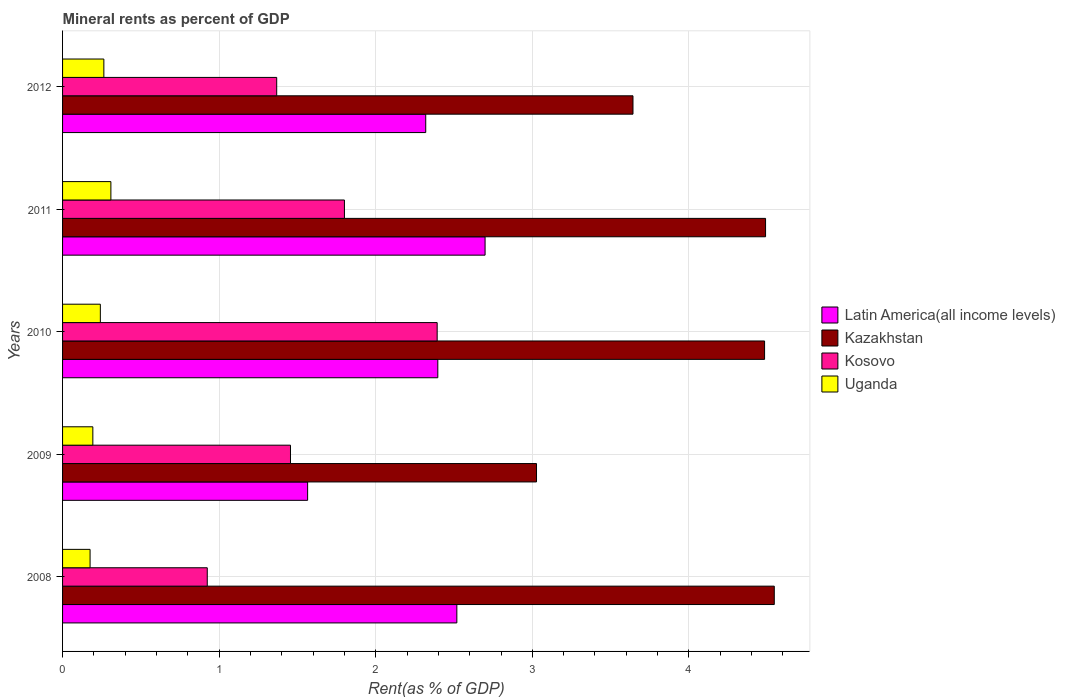How many different coloured bars are there?
Keep it short and to the point. 4. How many groups of bars are there?
Ensure brevity in your answer.  5. Are the number of bars per tick equal to the number of legend labels?
Keep it short and to the point. Yes. Are the number of bars on each tick of the Y-axis equal?
Your answer should be compact. Yes. How many bars are there on the 4th tick from the bottom?
Provide a short and direct response. 4. What is the mineral rent in Kosovo in 2012?
Your response must be concise. 1.37. Across all years, what is the maximum mineral rent in Kosovo?
Give a very brief answer. 2.39. Across all years, what is the minimum mineral rent in Uganda?
Keep it short and to the point. 0.18. What is the total mineral rent in Latin America(all income levels) in the graph?
Offer a very short reply. 11.5. What is the difference between the mineral rent in Latin America(all income levels) in 2008 and that in 2009?
Your response must be concise. 0.95. What is the difference between the mineral rent in Latin America(all income levels) in 2008 and the mineral rent in Uganda in 2012?
Your answer should be compact. 2.25. What is the average mineral rent in Kosovo per year?
Your answer should be compact. 1.59. In the year 2009, what is the difference between the mineral rent in Uganda and mineral rent in Latin America(all income levels)?
Your answer should be compact. -1.37. What is the ratio of the mineral rent in Latin America(all income levels) in 2010 to that in 2012?
Keep it short and to the point. 1.03. Is the difference between the mineral rent in Uganda in 2010 and 2012 greater than the difference between the mineral rent in Latin America(all income levels) in 2010 and 2012?
Offer a terse response. No. What is the difference between the highest and the second highest mineral rent in Latin America(all income levels)?
Give a very brief answer. 0.18. What is the difference between the highest and the lowest mineral rent in Uganda?
Offer a terse response. 0.13. In how many years, is the mineral rent in Latin America(all income levels) greater than the average mineral rent in Latin America(all income levels) taken over all years?
Make the answer very short. 4. Is the sum of the mineral rent in Uganda in 2011 and 2012 greater than the maximum mineral rent in Kosovo across all years?
Your answer should be very brief. No. Is it the case that in every year, the sum of the mineral rent in Uganda and mineral rent in Latin America(all income levels) is greater than the sum of mineral rent in Kosovo and mineral rent in Kazakhstan?
Keep it short and to the point. No. What does the 4th bar from the top in 2010 represents?
Offer a very short reply. Latin America(all income levels). What does the 1st bar from the bottom in 2011 represents?
Give a very brief answer. Latin America(all income levels). Are all the bars in the graph horizontal?
Your response must be concise. Yes. How many years are there in the graph?
Provide a short and direct response. 5. What is the difference between two consecutive major ticks on the X-axis?
Ensure brevity in your answer.  1. Does the graph contain grids?
Provide a short and direct response. Yes. Where does the legend appear in the graph?
Give a very brief answer. Center right. How many legend labels are there?
Provide a short and direct response. 4. How are the legend labels stacked?
Offer a terse response. Vertical. What is the title of the graph?
Offer a terse response. Mineral rents as percent of GDP. Does "Somalia" appear as one of the legend labels in the graph?
Your answer should be very brief. No. What is the label or title of the X-axis?
Make the answer very short. Rent(as % of GDP). What is the Rent(as % of GDP) of Latin America(all income levels) in 2008?
Make the answer very short. 2.52. What is the Rent(as % of GDP) in Kazakhstan in 2008?
Make the answer very short. 4.55. What is the Rent(as % of GDP) in Kosovo in 2008?
Give a very brief answer. 0.92. What is the Rent(as % of GDP) of Uganda in 2008?
Provide a short and direct response. 0.18. What is the Rent(as % of GDP) in Latin America(all income levels) in 2009?
Provide a short and direct response. 1.57. What is the Rent(as % of GDP) in Kazakhstan in 2009?
Give a very brief answer. 3.03. What is the Rent(as % of GDP) in Kosovo in 2009?
Provide a succinct answer. 1.46. What is the Rent(as % of GDP) of Uganda in 2009?
Your answer should be very brief. 0.19. What is the Rent(as % of GDP) of Latin America(all income levels) in 2010?
Your answer should be very brief. 2.4. What is the Rent(as % of GDP) in Kazakhstan in 2010?
Offer a very short reply. 4.48. What is the Rent(as % of GDP) of Kosovo in 2010?
Provide a short and direct response. 2.39. What is the Rent(as % of GDP) in Uganda in 2010?
Give a very brief answer. 0.24. What is the Rent(as % of GDP) in Latin America(all income levels) in 2011?
Offer a terse response. 2.7. What is the Rent(as % of GDP) of Kazakhstan in 2011?
Offer a very short reply. 4.49. What is the Rent(as % of GDP) of Kosovo in 2011?
Keep it short and to the point. 1.8. What is the Rent(as % of GDP) of Uganda in 2011?
Give a very brief answer. 0.31. What is the Rent(as % of GDP) in Latin America(all income levels) in 2012?
Ensure brevity in your answer.  2.32. What is the Rent(as % of GDP) in Kazakhstan in 2012?
Provide a succinct answer. 3.64. What is the Rent(as % of GDP) of Kosovo in 2012?
Keep it short and to the point. 1.37. What is the Rent(as % of GDP) in Uganda in 2012?
Offer a very short reply. 0.26. Across all years, what is the maximum Rent(as % of GDP) in Latin America(all income levels)?
Give a very brief answer. 2.7. Across all years, what is the maximum Rent(as % of GDP) of Kazakhstan?
Your answer should be very brief. 4.55. Across all years, what is the maximum Rent(as % of GDP) of Kosovo?
Your response must be concise. 2.39. Across all years, what is the maximum Rent(as % of GDP) in Uganda?
Offer a very short reply. 0.31. Across all years, what is the minimum Rent(as % of GDP) of Latin America(all income levels)?
Ensure brevity in your answer.  1.57. Across all years, what is the minimum Rent(as % of GDP) of Kazakhstan?
Your answer should be very brief. 3.03. Across all years, what is the minimum Rent(as % of GDP) in Kosovo?
Provide a short and direct response. 0.92. Across all years, what is the minimum Rent(as % of GDP) in Uganda?
Offer a terse response. 0.18. What is the total Rent(as % of GDP) in Latin America(all income levels) in the graph?
Your answer should be very brief. 11.5. What is the total Rent(as % of GDP) in Kazakhstan in the graph?
Your answer should be very brief. 20.19. What is the total Rent(as % of GDP) in Kosovo in the graph?
Your answer should be very brief. 7.94. What is the total Rent(as % of GDP) in Uganda in the graph?
Make the answer very short. 1.18. What is the difference between the Rent(as % of GDP) in Latin America(all income levels) in 2008 and that in 2009?
Your response must be concise. 0.95. What is the difference between the Rent(as % of GDP) of Kazakhstan in 2008 and that in 2009?
Offer a very short reply. 1.52. What is the difference between the Rent(as % of GDP) in Kosovo in 2008 and that in 2009?
Give a very brief answer. -0.53. What is the difference between the Rent(as % of GDP) of Uganda in 2008 and that in 2009?
Offer a very short reply. -0.02. What is the difference between the Rent(as % of GDP) in Latin America(all income levels) in 2008 and that in 2010?
Your answer should be very brief. 0.12. What is the difference between the Rent(as % of GDP) in Kazakhstan in 2008 and that in 2010?
Provide a short and direct response. 0.06. What is the difference between the Rent(as % of GDP) of Kosovo in 2008 and that in 2010?
Your answer should be compact. -1.47. What is the difference between the Rent(as % of GDP) of Uganda in 2008 and that in 2010?
Give a very brief answer. -0.07. What is the difference between the Rent(as % of GDP) of Latin America(all income levels) in 2008 and that in 2011?
Your answer should be compact. -0.18. What is the difference between the Rent(as % of GDP) of Kazakhstan in 2008 and that in 2011?
Ensure brevity in your answer.  0.06. What is the difference between the Rent(as % of GDP) in Kosovo in 2008 and that in 2011?
Provide a succinct answer. -0.88. What is the difference between the Rent(as % of GDP) of Uganda in 2008 and that in 2011?
Your answer should be compact. -0.13. What is the difference between the Rent(as % of GDP) in Latin America(all income levels) in 2008 and that in 2012?
Your response must be concise. 0.2. What is the difference between the Rent(as % of GDP) of Kazakhstan in 2008 and that in 2012?
Make the answer very short. 0.9. What is the difference between the Rent(as % of GDP) in Kosovo in 2008 and that in 2012?
Offer a terse response. -0.44. What is the difference between the Rent(as % of GDP) in Uganda in 2008 and that in 2012?
Provide a short and direct response. -0.09. What is the difference between the Rent(as % of GDP) of Latin America(all income levels) in 2009 and that in 2010?
Give a very brief answer. -0.83. What is the difference between the Rent(as % of GDP) in Kazakhstan in 2009 and that in 2010?
Provide a succinct answer. -1.46. What is the difference between the Rent(as % of GDP) in Kosovo in 2009 and that in 2010?
Offer a terse response. -0.94. What is the difference between the Rent(as % of GDP) in Uganda in 2009 and that in 2010?
Make the answer very short. -0.05. What is the difference between the Rent(as % of GDP) in Latin America(all income levels) in 2009 and that in 2011?
Offer a terse response. -1.13. What is the difference between the Rent(as % of GDP) of Kazakhstan in 2009 and that in 2011?
Ensure brevity in your answer.  -1.46. What is the difference between the Rent(as % of GDP) in Kosovo in 2009 and that in 2011?
Make the answer very short. -0.34. What is the difference between the Rent(as % of GDP) in Uganda in 2009 and that in 2011?
Your answer should be very brief. -0.12. What is the difference between the Rent(as % of GDP) in Latin America(all income levels) in 2009 and that in 2012?
Ensure brevity in your answer.  -0.75. What is the difference between the Rent(as % of GDP) in Kazakhstan in 2009 and that in 2012?
Your answer should be very brief. -0.62. What is the difference between the Rent(as % of GDP) in Kosovo in 2009 and that in 2012?
Your response must be concise. 0.09. What is the difference between the Rent(as % of GDP) in Uganda in 2009 and that in 2012?
Your response must be concise. -0.07. What is the difference between the Rent(as % of GDP) in Latin America(all income levels) in 2010 and that in 2011?
Your answer should be very brief. -0.3. What is the difference between the Rent(as % of GDP) of Kazakhstan in 2010 and that in 2011?
Your answer should be very brief. -0.01. What is the difference between the Rent(as % of GDP) in Kosovo in 2010 and that in 2011?
Keep it short and to the point. 0.59. What is the difference between the Rent(as % of GDP) of Uganda in 2010 and that in 2011?
Give a very brief answer. -0.07. What is the difference between the Rent(as % of GDP) in Latin America(all income levels) in 2010 and that in 2012?
Ensure brevity in your answer.  0.08. What is the difference between the Rent(as % of GDP) in Kazakhstan in 2010 and that in 2012?
Offer a very short reply. 0.84. What is the difference between the Rent(as % of GDP) in Kosovo in 2010 and that in 2012?
Your answer should be compact. 1.02. What is the difference between the Rent(as % of GDP) in Uganda in 2010 and that in 2012?
Provide a succinct answer. -0.02. What is the difference between the Rent(as % of GDP) of Latin America(all income levels) in 2011 and that in 2012?
Provide a succinct answer. 0.38. What is the difference between the Rent(as % of GDP) of Kazakhstan in 2011 and that in 2012?
Make the answer very short. 0.85. What is the difference between the Rent(as % of GDP) in Kosovo in 2011 and that in 2012?
Your response must be concise. 0.43. What is the difference between the Rent(as % of GDP) of Uganda in 2011 and that in 2012?
Provide a short and direct response. 0.04. What is the difference between the Rent(as % of GDP) in Latin America(all income levels) in 2008 and the Rent(as % of GDP) in Kazakhstan in 2009?
Offer a very short reply. -0.51. What is the difference between the Rent(as % of GDP) in Latin America(all income levels) in 2008 and the Rent(as % of GDP) in Kosovo in 2009?
Offer a terse response. 1.06. What is the difference between the Rent(as % of GDP) in Latin America(all income levels) in 2008 and the Rent(as % of GDP) in Uganda in 2009?
Make the answer very short. 2.32. What is the difference between the Rent(as % of GDP) of Kazakhstan in 2008 and the Rent(as % of GDP) of Kosovo in 2009?
Provide a succinct answer. 3.09. What is the difference between the Rent(as % of GDP) of Kazakhstan in 2008 and the Rent(as % of GDP) of Uganda in 2009?
Give a very brief answer. 4.35. What is the difference between the Rent(as % of GDP) in Kosovo in 2008 and the Rent(as % of GDP) in Uganda in 2009?
Provide a succinct answer. 0.73. What is the difference between the Rent(as % of GDP) of Latin America(all income levels) in 2008 and the Rent(as % of GDP) of Kazakhstan in 2010?
Give a very brief answer. -1.97. What is the difference between the Rent(as % of GDP) of Latin America(all income levels) in 2008 and the Rent(as % of GDP) of Kosovo in 2010?
Offer a terse response. 0.13. What is the difference between the Rent(as % of GDP) in Latin America(all income levels) in 2008 and the Rent(as % of GDP) in Uganda in 2010?
Give a very brief answer. 2.28. What is the difference between the Rent(as % of GDP) of Kazakhstan in 2008 and the Rent(as % of GDP) of Kosovo in 2010?
Offer a very short reply. 2.15. What is the difference between the Rent(as % of GDP) in Kazakhstan in 2008 and the Rent(as % of GDP) in Uganda in 2010?
Offer a terse response. 4.3. What is the difference between the Rent(as % of GDP) of Kosovo in 2008 and the Rent(as % of GDP) of Uganda in 2010?
Keep it short and to the point. 0.68. What is the difference between the Rent(as % of GDP) of Latin America(all income levels) in 2008 and the Rent(as % of GDP) of Kazakhstan in 2011?
Make the answer very short. -1.97. What is the difference between the Rent(as % of GDP) in Latin America(all income levels) in 2008 and the Rent(as % of GDP) in Kosovo in 2011?
Your answer should be very brief. 0.72. What is the difference between the Rent(as % of GDP) in Latin America(all income levels) in 2008 and the Rent(as % of GDP) in Uganda in 2011?
Offer a terse response. 2.21. What is the difference between the Rent(as % of GDP) in Kazakhstan in 2008 and the Rent(as % of GDP) in Kosovo in 2011?
Offer a very short reply. 2.75. What is the difference between the Rent(as % of GDP) in Kazakhstan in 2008 and the Rent(as % of GDP) in Uganda in 2011?
Provide a short and direct response. 4.24. What is the difference between the Rent(as % of GDP) in Kosovo in 2008 and the Rent(as % of GDP) in Uganda in 2011?
Offer a very short reply. 0.62. What is the difference between the Rent(as % of GDP) in Latin America(all income levels) in 2008 and the Rent(as % of GDP) in Kazakhstan in 2012?
Offer a very short reply. -1.12. What is the difference between the Rent(as % of GDP) of Latin America(all income levels) in 2008 and the Rent(as % of GDP) of Kosovo in 2012?
Your answer should be very brief. 1.15. What is the difference between the Rent(as % of GDP) of Latin America(all income levels) in 2008 and the Rent(as % of GDP) of Uganda in 2012?
Make the answer very short. 2.25. What is the difference between the Rent(as % of GDP) in Kazakhstan in 2008 and the Rent(as % of GDP) in Kosovo in 2012?
Offer a terse response. 3.18. What is the difference between the Rent(as % of GDP) in Kazakhstan in 2008 and the Rent(as % of GDP) in Uganda in 2012?
Your response must be concise. 4.28. What is the difference between the Rent(as % of GDP) of Kosovo in 2008 and the Rent(as % of GDP) of Uganda in 2012?
Your answer should be compact. 0.66. What is the difference between the Rent(as % of GDP) of Latin America(all income levels) in 2009 and the Rent(as % of GDP) of Kazakhstan in 2010?
Your response must be concise. -2.92. What is the difference between the Rent(as % of GDP) in Latin America(all income levels) in 2009 and the Rent(as % of GDP) in Kosovo in 2010?
Give a very brief answer. -0.83. What is the difference between the Rent(as % of GDP) in Latin America(all income levels) in 2009 and the Rent(as % of GDP) in Uganda in 2010?
Offer a very short reply. 1.32. What is the difference between the Rent(as % of GDP) of Kazakhstan in 2009 and the Rent(as % of GDP) of Kosovo in 2010?
Your answer should be very brief. 0.63. What is the difference between the Rent(as % of GDP) in Kazakhstan in 2009 and the Rent(as % of GDP) in Uganda in 2010?
Ensure brevity in your answer.  2.79. What is the difference between the Rent(as % of GDP) in Kosovo in 2009 and the Rent(as % of GDP) in Uganda in 2010?
Provide a short and direct response. 1.21. What is the difference between the Rent(as % of GDP) of Latin America(all income levels) in 2009 and the Rent(as % of GDP) of Kazakhstan in 2011?
Ensure brevity in your answer.  -2.92. What is the difference between the Rent(as % of GDP) of Latin America(all income levels) in 2009 and the Rent(as % of GDP) of Kosovo in 2011?
Offer a very short reply. -0.23. What is the difference between the Rent(as % of GDP) in Latin America(all income levels) in 2009 and the Rent(as % of GDP) in Uganda in 2011?
Provide a short and direct response. 1.26. What is the difference between the Rent(as % of GDP) in Kazakhstan in 2009 and the Rent(as % of GDP) in Kosovo in 2011?
Make the answer very short. 1.23. What is the difference between the Rent(as % of GDP) of Kazakhstan in 2009 and the Rent(as % of GDP) of Uganda in 2011?
Keep it short and to the point. 2.72. What is the difference between the Rent(as % of GDP) of Kosovo in 2009 and the Rent(as % of GDP) of Uganda in 2011?
Make the answer very short. 1.15. What is the difference between the Rent(as % of GDP) in Latin America(all income levels) in 2009 and the Rent(as % of GDP) in Kazakhstan in 2012?
Keep it short and to the point. -2.08. What is the difference between the Rent(as % of GDP) of Latin America(all income levels) in 2009 and the Rent(as % of GDP) of Kosovo in 2012?
Offer a terse response. 0.2. What is the difference between the Rent(as % of GDP) of Latin America(all income levels) in 2009 and the Rent(as % of GDP) of Uganda in 2012?
Your answer should be compact. 1.3. What is the difference between the Rent(as % of GDP) in Kazakhstan in 2009 and the Rent(as % of GDP) in Kosovo in 2012?
Provide a short and direct response. 1.66. What is the difference between the Rent(as % of GDP) in Kazakhstan in 2009 and the Rent(as % of GDP) in Uganda in 2012?
Offer a terse response. 2.76. What is the difference between the Rent(as % of GDP) of Kosovo in 2009 and the Rent(as % of GDP) of Uganda in 2012?
Offer a terse response. 1.19. What is the difference between the Rent(as % of GDP) in Latin America(all income levels) in 2010 and the Rent(as % of GDP) in Kazakhstan in 2011?
Your answer should be compact. -2.09. What is the difference between the Rent(as % of GDP) in Latin America(all income levels) in 2010 and the Rent(as % of GDP) in Kosovo in 2011?
Keep it short and to the point. 0.6. What is the difference between the Rent(as % of GDP) of Latin America(all income levels) in 2010 and the Rent(as % of GDP) of Uganda in 2011?
Provide a short and direct response. 2.09. What is the difference between the Rent(as % of GDP) in Kazakhstan in 2010 and the Rent(as % of GDP) in Kosovo in 2011?
Keep it short and to the point. 2.68. What is the difference between the Rent(as % of GDP) of Kazakhstan in 2010 and the Rent(as % of GDP) of Uganda in 2011?
Your answer should be very brief. 4.17. What is the difference between the Rent(as % of GDP) in Kosovo in 2010 and the Rent(as % of GDP) in Uganda in 2011?
Your response must be concise. 2.08. What is the difference between the Rent(as % of GDP) in Latin America(all income levels) in 2010 and the Rent(as % of GDP) in Kazakhstan in 2012?
Offer a very short reply. -1.25. What is the difference between the Rent(as % of GDP) of Latin America(all income levels) in 2010 and the Rent(as % of GDP) of Kosovo in 2012?
Your answer should be very brief. 1.03. What is the difference between the Rent(as % of GDP) in Latin America(all income levels) in 2010 and the Rent(as % of GDP) in Uganda in 2012?
Provide a succinct answer. 2.13. What is the difference between the Rent(as % of GDP) in Kazakhstan in 2010 and the Rent(as % of GDP) in Kosovo in 2012?
Keep it short and to the point. 3.12. What is the difference between the Rent(as % of GDP) in Kazakhstan in 2010 and the Rent(as % of GDP) in Uganda in 2012?
Offer a very short reply. 4.22. What is the difference between the Rent(as % of GDP) of Kosovo in 2010 and the Rent(as % of GDP) of Uganda in 2012?
Provide a succinct answer. 2.13. What is the difference between the Rent(as % of GDP) of Latin America(all income levels) in 2011 and the Rent(as % of GDP) of Kazakhstan in 2012?
Provide a short and direct response. -0.94. What is the difference between the Rent(as % of GDP) of Latin America(all income levels) in 2011 and the Rent(as % of GDP) of Kosovo in 2012?
Your answer should be compact. 1.33. What is the difference between the Rent(as % of GDP) of Latin America(all income levels) in 2011 and the Rent(as % of GDP) of Uganda in 2012?
Offer a terse response. 2.43. What is the difference between the Rent(as % of GDP) of Kazakhstan in 2011 and the Rent(as % of GDP) of Kosovo in 2012?
Ensure brevity in your answer.  3.12. What is the difference between the Rent(as % of GDP) of Kazakhstan in 2011 and the Rent(as % of GDP) of Uganda in 2012?
Your response must be concise. 4.23. What is the difference between the Rent(as % of GDP) of Kosovo in 2011 and the Rent(as % of GDP) of Uganda in 2012?
Make the answer very short. 1.54. What is the average Rent(as % of GDP) in Latin America(all income levels) per year?
Make the answer very short. 2.3. What is the average Rent(as % of GDP) of Kazakhstan per year?
Ensure brevity in your answer.  4.04. What is the average Rent(as % of GDP) in Kosovo per year?
Your answer should be very brief. 1.59. What is the average Rent(as % of GDP) of Uganda per year?
Your answer should be very brief. 0.24. In the year 2008, what is the difference between the Rent(as % of GDP) in Latin America(all income levels) and Rent(as % of GDP) in Kazakhstan?
Offer a very short reply. -2.03. In the year 2008, what is the difference between the Rent(as % of GDP) in Latin America(all income levels) and Rent(as % of GDP) in Kosovo?
Your answer should be very brief. 1.59. In the year 2008, what is the difference between the Rent(as % of GDP) in Latin America(all income levels) and Rent(as % of GDP) in Uganda?
Provide a short and direct response. 2.34. In the year 2008, what is the difference between the Rent(as % of GDP) of Kazakhstan and Rent(as % of GDP) of Kosovo?
Your answer should be compact. 3.62. In the year 2008, what is the difference between the Rent(as % of GDP) in Kazakhstan and Rent(as % of GDP) in Uganda?
Offer a terse response. 4.37. In the year 2008, what is the difference between the Rent(as % of GDP) of Kosovo and Rent(as % of GDP) of Uganda?
Keep it short and to the point. 0.75. In the year 2009, what is the difference between the Rent(as % of GDP) in Latin America(all income levels) and Rent(as % of GDP) in Kazakhstan?
Your response must be concise. -1.46. In the year 2009, what is the difference between the Rent(as % of GDP) of Latin America(all income levels) and Rent(as % of GDP) of Kosovo?
Your answer should be very brief. 0.11. In the year 2009, what is the difference between the Rent(as % of GDP) in Latin America(all income levels) and Rent(as % of GDP) in Uganda?
Offer a very short reply. 1.37. In the year 2009, what is the difference between the Rent(as % of GDP) of Kazakhstan and Rent(as % of GDP) of Kosovo?
Make the answer very short. 1.57. In the year 2009, what is the difference between the Rent(as % of GDP) of Kazakhstan and Rent(as % of GDP) of Uganda?
Your answer should be very brief. 2.83. In the year 2009, what is the difference between the Rent(as % of GDP) of Kosovo and Rent(as % of GDP) of Uganda?
Your answer should be very brief. 1.26. In the year 2010, what is the difference between the Rent(as % of GDP) in Latin America(all income levels) and Rent(as % of GDP) in Kazakhstan?
Provide a succinct answer. -2.09. In the year 2010, what is the difference between the Rent(as % of GDP) of Latin America(all income levels) and Rent(as % of GDP) of Kosovo?
Keep it short and to the point. 0. In the year 2010, what is the difference between the Rent(as % of GDP) of Latin America(all income levels) and Rent(as % of GDP) of Uganda?
Make the answer very short. 2.16. In the year 2010, what is the difference between the Rent(as % of GDP) of Kazakhstan and Rent(as % of GDP) of Kosovo?
Make the answer very short. 2.09. In the year 2010, what is the difference between the Rent(as % of GDP) in Kazakhstan and Rent(as % of GDP) in Uganda?
Provide a short and direct response. 4.24. In the year 2010, what is the difference between the Rent(as % of GDP) in Kosovo and Rent(as % of GDP) in Uganda?
Keep it short and to the point. 2.15. In the year 2011, what is the difference between the Rent(as % of GDP) in Latin America(all income levels) and Rent(as % of GDP) in Kazakhstan?
Your answer should be compact. -1.79. In the year 2011, what is the difference between the Rent(as % of GDP) in Latin America(all income levels) and Rent(as % of GDP) in Kosovo?
Your response must be concise. 0.9. In the year 2011, what is the difference between the Rent(as % of GDP) in Latin America(all income levels) and Rent(as % of GDP) in Uganda?
Your answer should be very brief. 2.39. In the year 2011, what is the difference between the Rent(as % of GDP) in Kazakhstan and Rent(as % of GDP) in Kosovo?
Give a very brief answer. 2.69. In the year 2011, what is the difference between the Rent(as % of GDP) in Kazakhstan and Rent(as % of GDP) in Uganda?
Your answer should be very brief. 4.18. In the year 2011, what is the difference between the Rent(as % of GDP) of Kosovo and Rent(as % of GDP) of Uganda?
Your answer should be compact. 1.49. In the year 2012, what is the difference between the Rent(as % of GDP) of Latin America(all income levels) and Rent(as % of GDP) of Kazakhstan?
Your answer should be very brief. -1.32. In the year 2012, what is the difference between the Rent(as % of GDP) of Latin America(all income levels) and Rent(as % of GDP) of Kosovo?
Your answer should be compact. 0.95. In the year 2012, what is the difference between the Rent(as % of GDP) in Latin America(all income levels) and Rent(as % of GDP) in Uganda?
Your answer should be very brief. 2.06. In the year 2012, what is the difference between the Rent(as % of GDP) of Kazakhstan and Rent(as % of GDP) of Kosovo?
Keep it short and to the point. 2.28. In the year 2012, what is the difference between the Rent(as % of GDP) of Kazakhstan and Rent(as % of GDP) of Uganda?
Provide a short and direct response. 3.38. In the year 2012, what is the difference between the Rent(as % of GDP) of Kosovo and Rent(as % of GDP) of Uganda?
Keep it short and to the point. 1.1. What is the ratio of the Rent(as % of GDP) of Latin America(all income levels) in 2008 to that in 2009?
Keep it short and to the point. 1.61. What is the ratio of the Rent(as % of GDP) in Kazakhstan in 2008 to that in 2009?
Your response must be concise. 1.5. What is the ratio of the Rent(as % of GDP) of Kosovo in 2008 to that in 2009?
Provide a short and direct response. 0.63. What is the ratio of the Rent(as % of GDP) in Uganda in 2008 to that in 2009?
Give a very brief answer. 0.91. What is the ratio of the Rent(as % of GDP) of Latin America(all income levels) in 2008 to that in 2010?
Provide a succinct answer. 1.05. What is the ratio of the Rent(as % of GDP) in Kazakhstan in 2008 to that in 2010?
Keep it short and to the point. 1.01. What is the ratio of the Rent(as % of GDP) of Kosovo in 2008 to that in 2010?
Keep it short and to the point. 0.39. What is the ratio of the Rent(as % of GDP) in Uganda in 2008 to that in 2010?
Make the answer very short. 0.73. What is the ratio of the Rent(as % of GDP) of Latin America(all income levels) in 2008 to that in 2011?
Ensure brevity in your answer.  0.93. What is the ratio of the Rent(as % of GDP) of Kazakhstan in 2008 to that in 2011?
Your answer should be very brief. 1.01. What is the ratio of the Rent(as % of GDP) in Kosovo in 2008 to that in 2011?
Your answer should be compact. 0.51. What is the ratio of the Rent(as % of GDP) of Uganda in 2008 to that in 2011?
Make the answer very short. 0.57. What is the ratio of the Rent(as % of GDP) in Latin America(all income levels) in 2008 to that in 2012?
Ensure brevity in your answer.  1.09. What is the ratio of the Rent(as % of GDP) of Kazakhstan in 2008 to that in 2012?
Your answer should be very brief. 1.25. What is the ratio of the Rent(as % of GDP) in Kosovo in 2008 to that in 2012?
Ensure brevity in your answer.  0.68. What is the ratio of the Rent(as % of GDP) in Uganda in 2008 to that in 2012?
Your answer should be compact. 0.67. What is the ratio of the Rent(as % of GDP) in Latin America(all income levels) in 2009 to that in 2010?
Keep it short and to the point. 0.65. What is the ratio of the Rent(as % of GDP) in Kazakhstan in 2009 to that in 2010?
Ensure brevity in your answer.  0.68. What is the ratio of the Rent(as % of GDP) in Kosovo in 2009 to that in 2010?
Your answer should be very brief. 0.61. What is the ratio of the Rent(as % of GDP) in Uganda in 2009 to that in 2010?
Make the answer very short. 0.8. What is the ratio of the Rent(as % of GDP) in Latin America(all income levels) in 2009 to that in 2011?
Offer a terse response. 0.58. What is the ratio of the Rent(as % of GDP) in Kazakhstan in 2009 to that in 2011?
Keep it short and to the point. 0.67. What is the ratio of the Rent(as % of GDP) of Kosovo in 2009 to that in 2011?
Provide a short and direct response. 0.81. What is the ratio of the Rent(as % of GDP) of Uganda in 2009 to that in 2011?
Offer a very short reply. 0.63. What is the ratio of the Rent(as % of GDP) of Latin America(all income levels) in 2009 to that in 2012?
Offer a terse response. 0.67. What is the ratio of the Rent(as % of GDP) of Kazakhstan in 2009 to that in 2012?
Your response must be concise. 0.83. What is the ratio of the Rent(as % of GDP) in Kosovo in 2009 to that in 2012?
Keep it short and to the point. 1.06. What is the ratio of the Rent(as % of GDP) in Uganda in 2009 to that in 2012?
Offer a terse response. 0.73. What is the ratio of the Rent(as % of GDP) in Latin America(all income levels) in 2010 to that in 2011?
Ensure brevity in your answer.  0.89. What is the ratio of the Rent(as % of GDP) of Kosovo in 2010 to that in 2011?
Ensure brevity in your answer.  1.33. What is the ratio of the Rent(as % of GDP) in Uganda in 2010 to that in 2011?
Offer a terse response. 0.78. What is the ratio of the Rent(as % of GDP) of Latin America(all income levels) in 2010 to that in 2012?
Provide a succinct answer. 1.03. What is the ratio of the Rent(as % of GDP) of Kazakhstan in 2010 to that in 2012?
Provide a succinct answer. 1.23. What is the ratio of the Rent(as % of GDP) of Kosovo in 2010 to that in 2012?
Your answer should be compact. 1.75. What is the ratio of the Rent(as % of GDP) of Uganda in 2010 to that in 2012?
Provide a succinct answer. 0.92. What is the ratio of the Rent(as % of GDP) in Latin America(all income levels) in 2011 to that in 2012?
Offer a very short reply. 1.16. What is the ratio of the Rent(as % of GDP) of Kazakhstan in 2011 to that in 2012?
Give a very brief answer. 1.23. What is the ratio of the Rent(as % of GDP) in Kosovo in 2011 to that in 2012?
Ensure brevity in your answer.  1.32. What is the ratio of the Rent(as % of GDP) in Uganda in 2011 to that in 2012?
Offer a terse response. 1.17. What is the difference between the highest and the second highest Rent(as % of GDP) in Latin America(all income levels)?
Offer a very short reply. 0.18. What is the difference between the highest and the second highest Rent(as % of GDP) in Kazakhstan?
Give a very brief answer. 0.06. What is the difference between the highest and the second highest Rent(as % of GDP) in Kosovo?
Provide a short and direct response. 0.59. What is the difference between the highest and the second highest Rent(as % of GDP) in Uganda?
Make the answer very short. 0.04. What is the difference between the highest and the lowest Rent(as % of GDP) in Latin America(all income levels)?
Provide a short and direct response. 1.13. What is the difference between the highest and the lowest Rent(as % of GDP) in Kazakhstan?
Provide a short and direct response. 1.52. What is the difference between the highest and the lowest Rent(as % of GDP) of Kosovo?
Provide a succinct answer. 1.47. What is the difference between the highest and the lowest Rent(as % of GDP) of Uganda?
Ensure brevity in your answer.  0.13. 